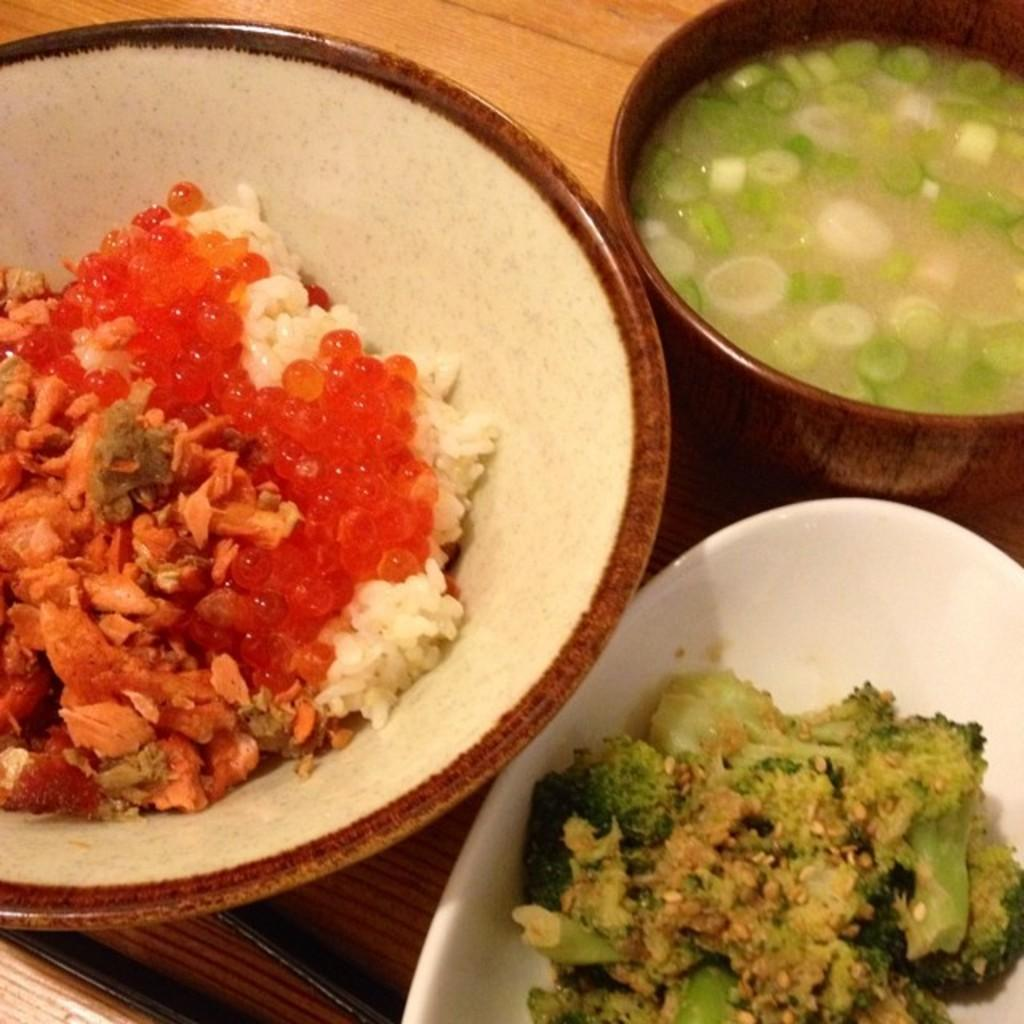What types of food items can be seen in the image? There are food items in the image, but their specific types are not mentioned. Where are the bowls located in the image? The bowls are on the table in the image. What is the purpose of the holder in the image? The purpose of the holder in the image is not specified. How many cats are sitting on the plate in the image? There are no cats present in the image; it only features food items, bowls, and a holder on the table. 